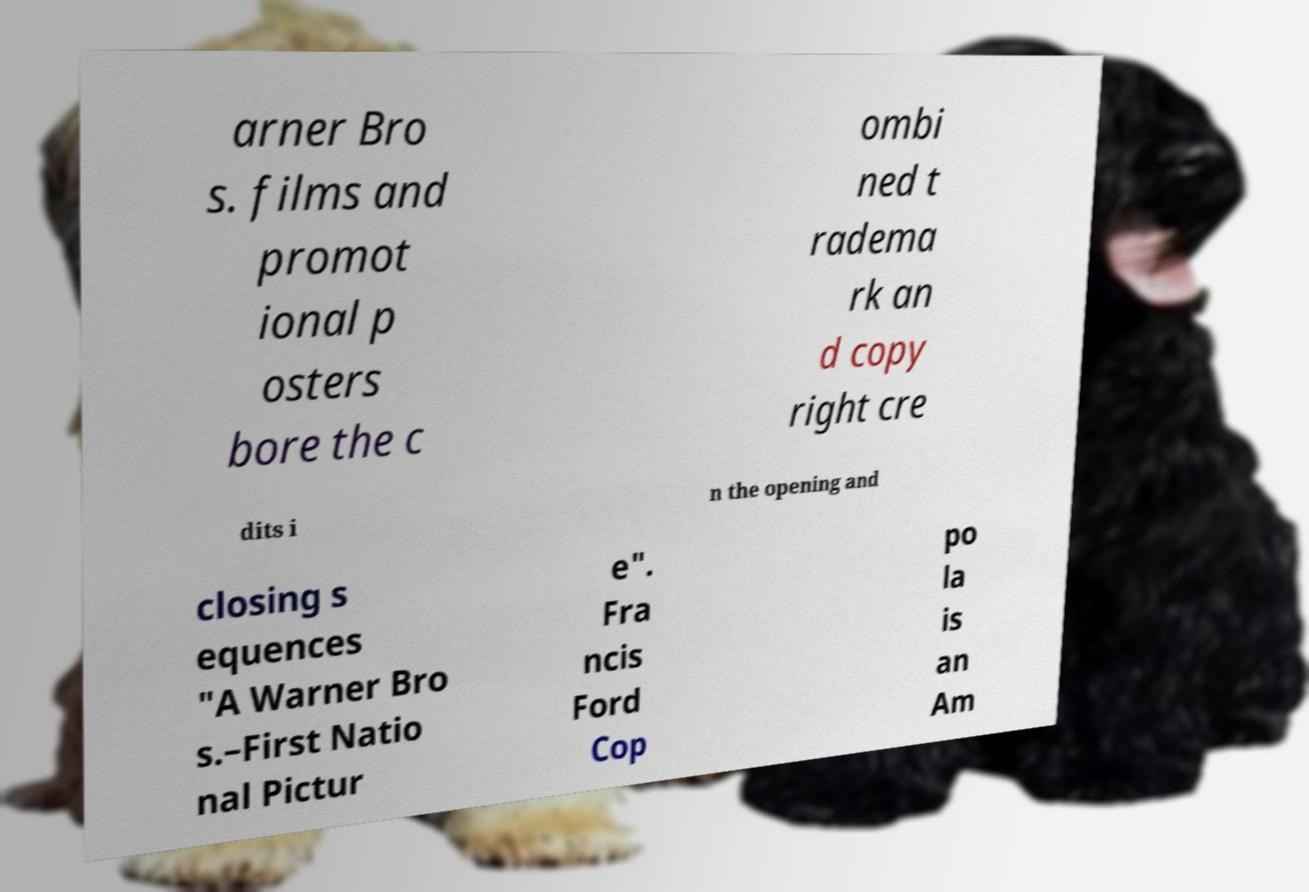Can you read and provide the text displayed in the image?This photo seems to have some interesting text. Can you extract and type it out for me? arner Bro s. films and promot ional p osters bore the c ombi ned t radema rk an d copy right cre dits i n the opening and closing s equences "A Warner Bro s.–First Natio nal Pictur e". Fra ncis Ford Cop po la is an Am 